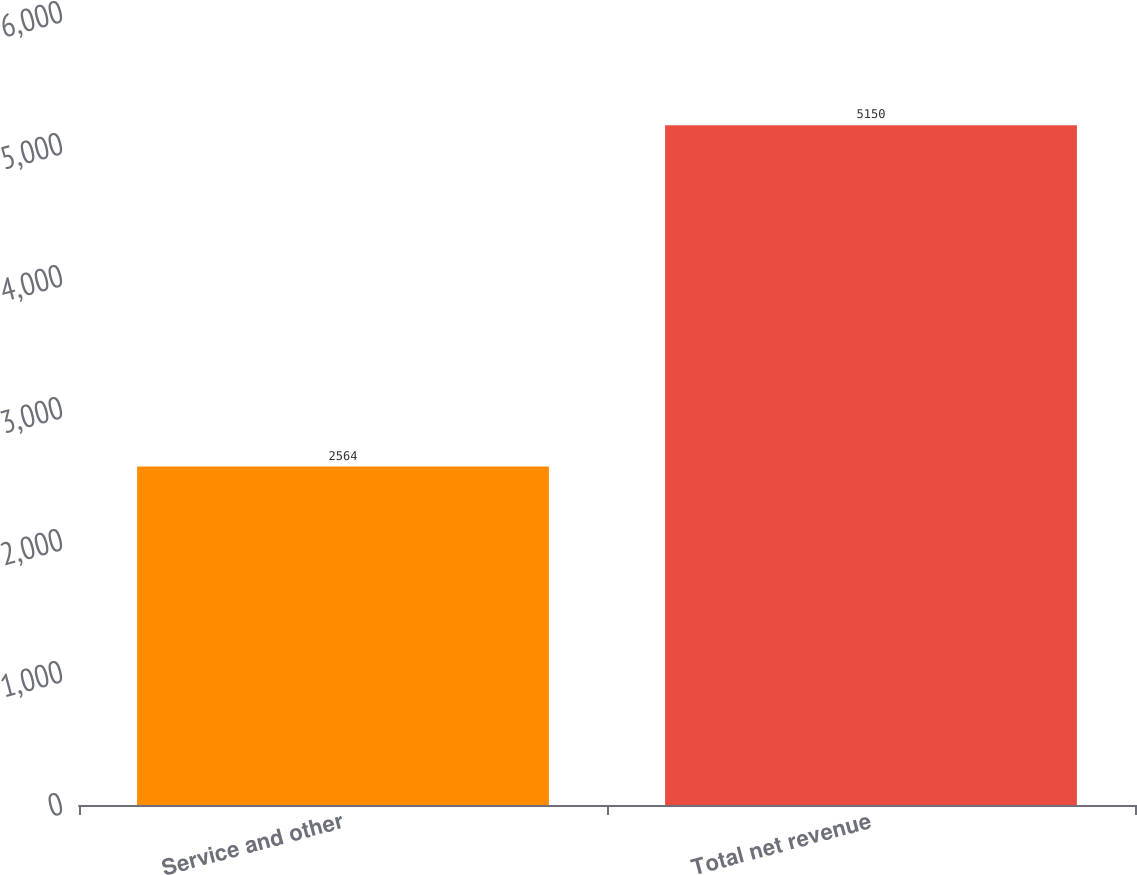Convert chart to OTSL. <chart><loc_0><loc_0><loc_500><loc_500><bar_chart><fcel>Service and other<fcel>Total net revenue<nl><fcel>2564<fcel>5150<nl></chart> 